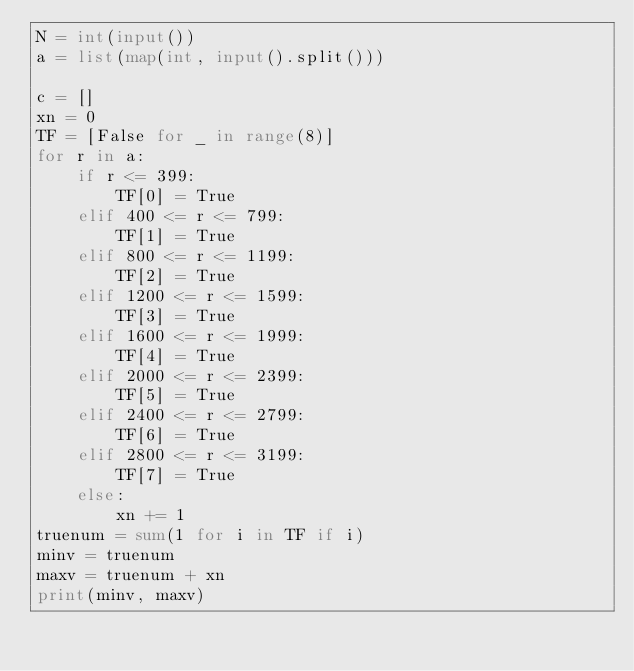Convert code to text. <code><loc_0><loc_0><loc_500><loc_500><_Python_>N = int(input())
a = list(map(int, input().split()))

c = []
xn = 0
TF = [False for _ in range(8)]
for r in a:
    if r <= 399:
        TF[0] = True
    elif 400 <= r <= 799:
        TF[1] = True
    elif 800 <= r <= 1199:
        TF[2] = True
    elif 1200 <= r <= 1599:
        TF[3] = True
    elif 1600 <= r <= 1999:
        TF[4] = True
    elif 2000 <= r <= 2399:
        TF[5] = True
    elif 2400 <= r <= 2799:
        TF[6] = True
    elif 2800 <= r <= 3199:
        TF[7] = True
    else:
        xn += 1
truenum = sum(1 for i in TF if i)
minv = truenum
maxv = truenum + xn
print(minv, maxv)</code> 